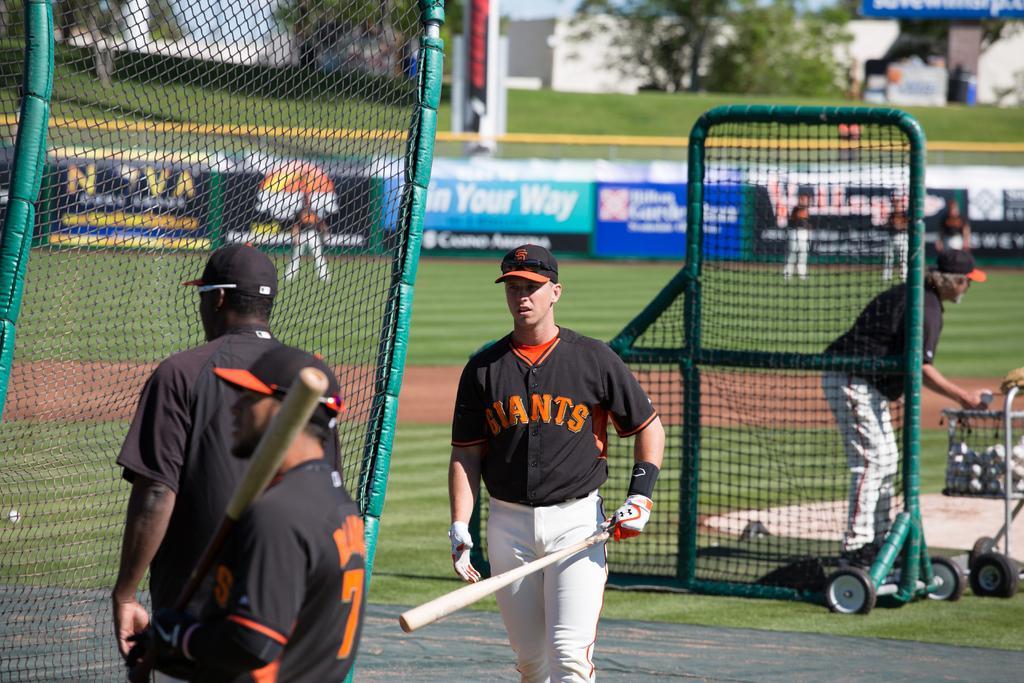How would you summarize this image in a sentence or two? In this image, there are a few people. Among them, some people are holding objects. We can see the ground with some grass and objects. We can also see some green colored objects with the net. We can also see a trolley with some balls on the right. There are a few trees, some white colored objects and poles. We can also see the sky and some boards with text and images. 